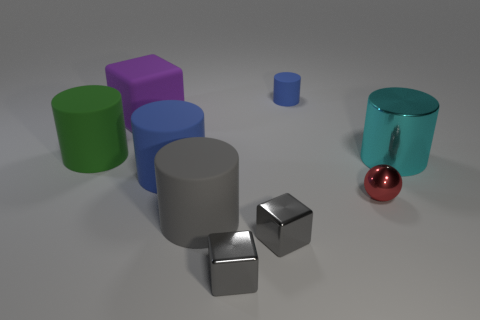Do the cylinder left of the large purple block and the blue cylinder left of the gray cylinder have the same material?
Keep it short and to the point. Yes. Are there the same number of tiny balls that are to the left of the gray rubber cylinder and rubber cylinders in front of the large cyan shiny object?
Make the answer very short. No. There is a block that is the same size as the green thing; what color is it?
Offer a very short reply. Purple. Is there a matte object of the same color as the small metal sphere?
Ensure brevity in your answer.  No. How many objects are either big rubber objects that are in front of the tiny blue matte object or large green objects?
Provide a short and direct response. 4. What number of other objects are there of the same size as the gray cylinder?
Provide a short and direct response. 4. What is the material of the blue cylinder in front of the matte object that is on the left side of the cube that is behind the small red object?
Offer a terse response. Rubber. How many cubes are large blue rubber objects or tiny shiny objects?
Your answer should be compact. 2. Is there anything else that is the same shape as the tiny red shiny thing?
Keep it short and to the point. No. Is the number of shiny spheres that are behind the green matte cylinder greater than the number of large gray cylinders behind the large cyan metal thing?
Ensure brevity in your answer.  No. 